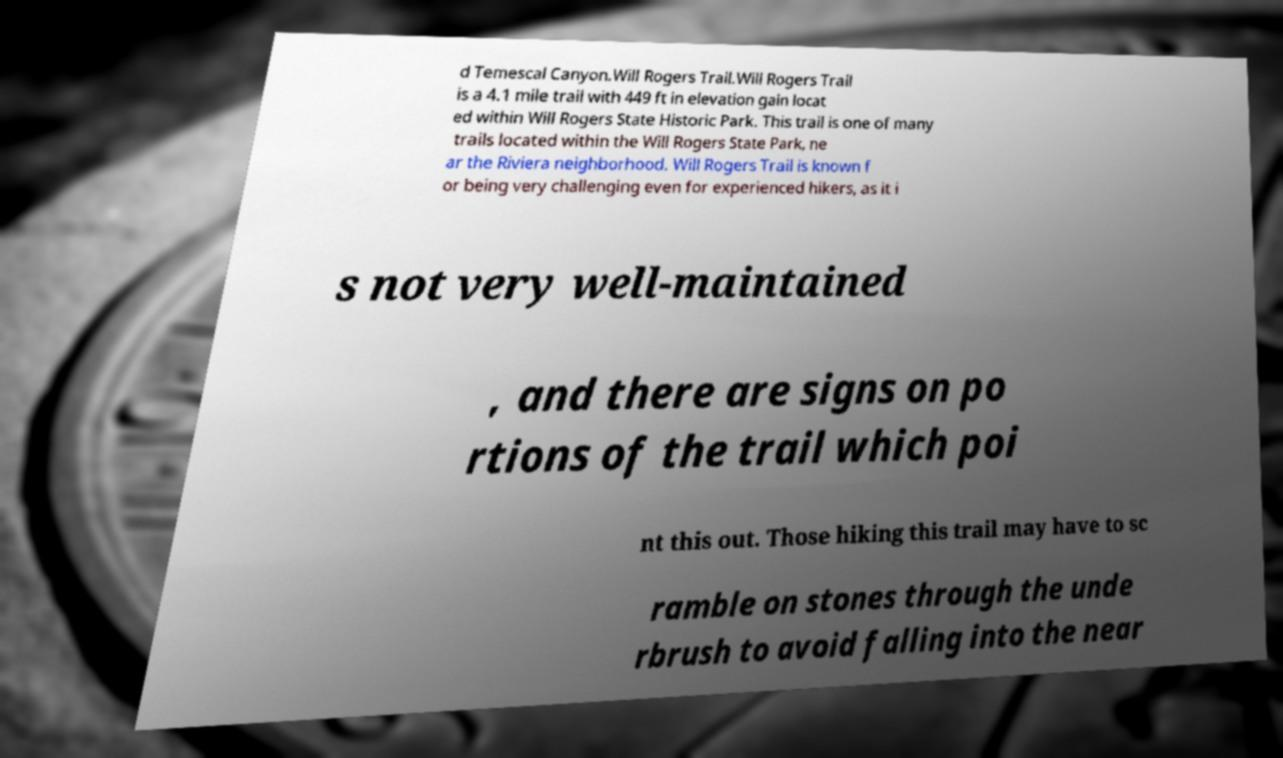For documentation purposes, I need the text within this image transcribed. Could you provide that? d Temescal Canyon.Will Rogers Trail.Will Rogers Trail is a 4.1 mile trail with 449 ft in elevation gain locat ed within Will Rogers State Historic Park. This trail is one of many trails located within the Will Rogers State Park, ne ar the Riviera neighborhood. Will Rogers Trail is known f or being very challenging even for experienced hikers, as it i s not very well-maintained , and there are signs on po rtions of the trail which poi nt this out. Those hiking this trail may have to sc ramble on stones through the unde rbrush to avoid falling into the near 